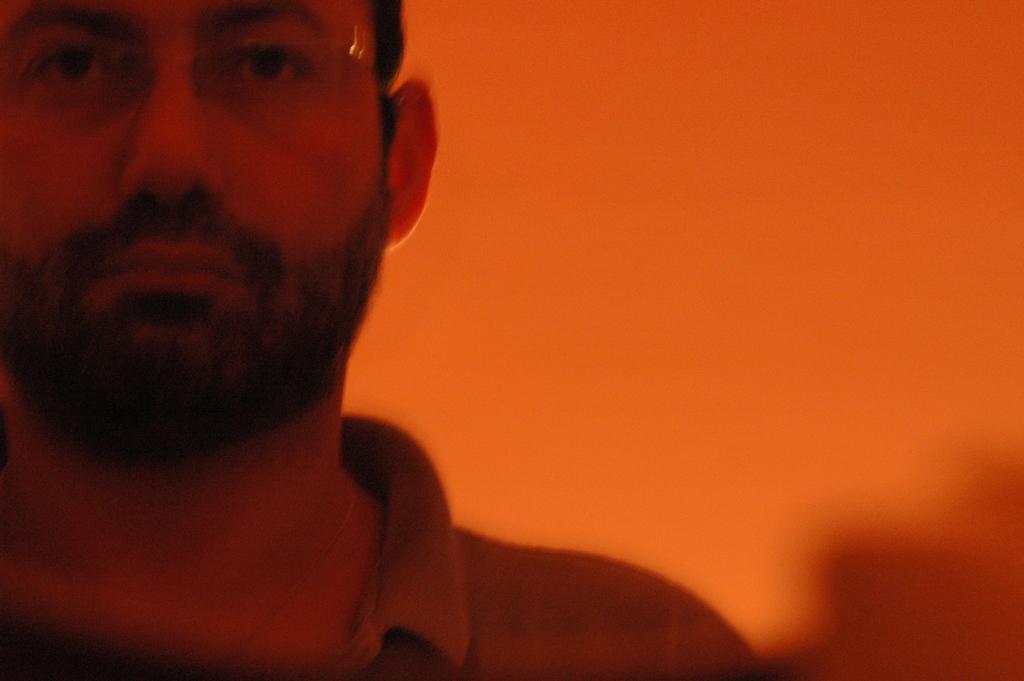Describe this image in one or two sentences. In this image we can see a man. The background is blurry. 